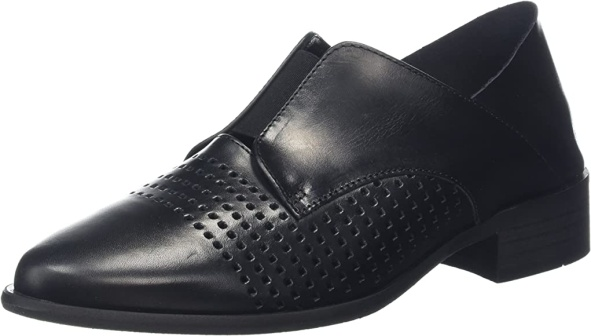Can you describe a scenario where this shoe would be the perfect fit? Imagine attending a sophisticated evening gala hosted in a grand, historic mansion. The elegantly lit ballroom, filled with the murmur of refined conversations and the gentle clinking of champagne glasses, sets the scene perfectly. This black leather shoe, with its understated elegance and smart detailing, would be the ideal choice for such an occasion. Its classic look ensures it pairs seamlessly with a formal suit, providing a stylish yet comfortable option for a night of socializing and dancing. 